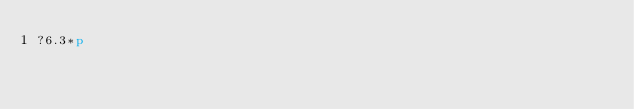<code> <loc_0><loc_0><loc_500><loc_500><_dc_>?6.3*p</code> 